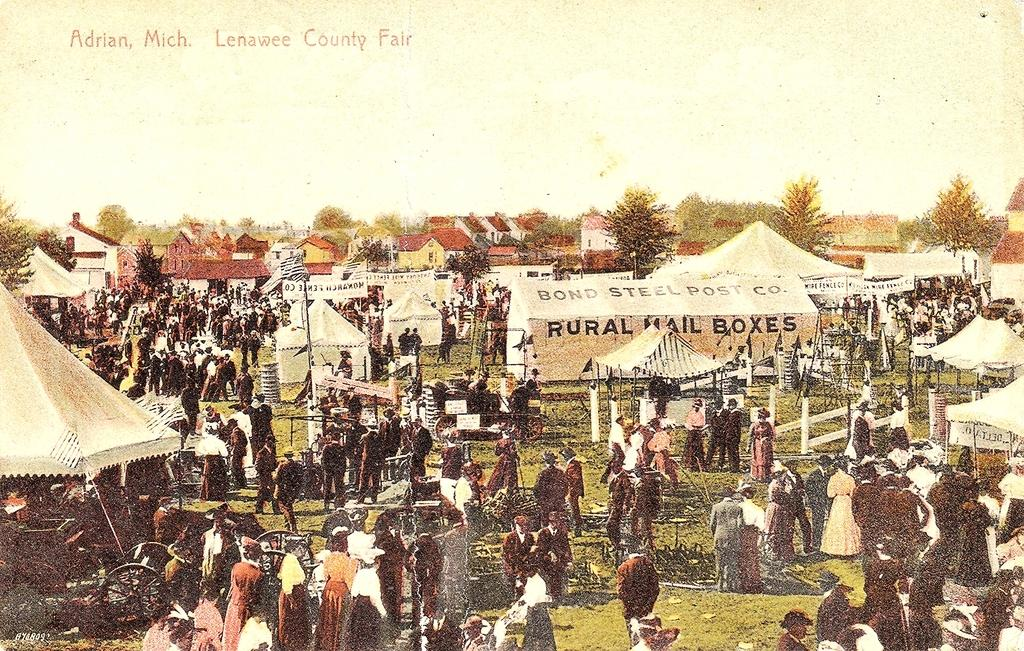<image>
Relay a brief, clear account of the picture shown. A vinatge drawing depicts the Lenawee County Fair in Adrian, Michigan where festival attendees stand near tents and a large, rural mail box tent. 